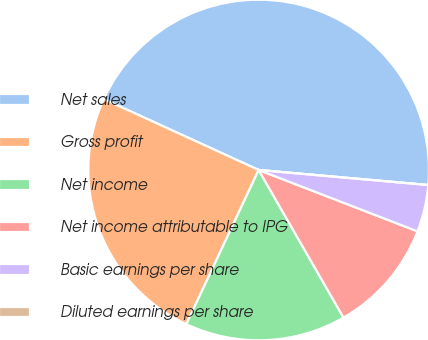Convert chart to OTSL. <chart><loc_0><loc_0><loc_500><loc_500><pie_chart><fcel>Net sales<fcel>Gross profit<fcel>Net income<fcel>Net income attributable to IPG<fcel>Basic earnings per share<fcel>Diluted earnings per share<nl><fcel>44.58%<fcel>24.85%<fcel>15.28%<fcel>10.83%<fcel>4.46%<fcel>0.0%<nl></chart> 